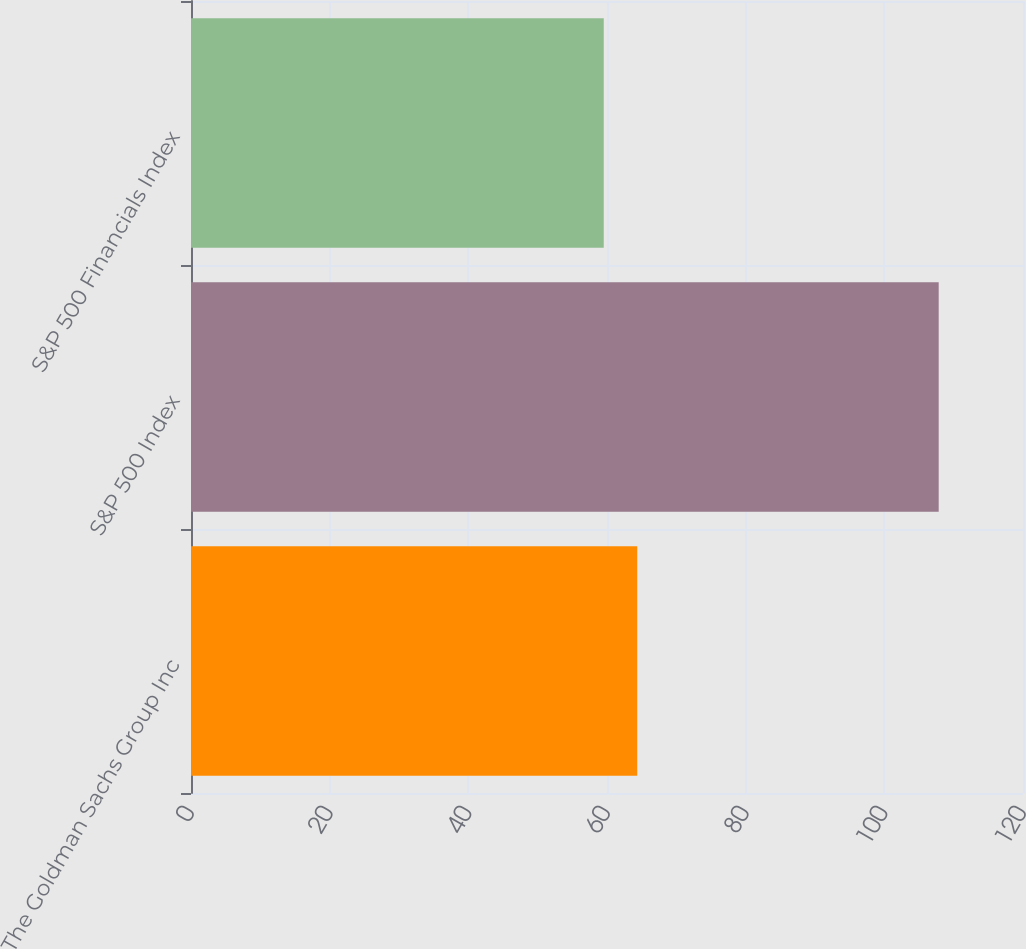Convert chart. <chart><loc_0><loc_0><loc_500><loc_500><bar_chart><fcel>The Goldman Sachs Group Inc<fcel>S&P 500 Index<fcel>S&P 500 Financials Index<nl><fcel>64.36<fcel>107.84<fcel>59.53<nl></chart> 